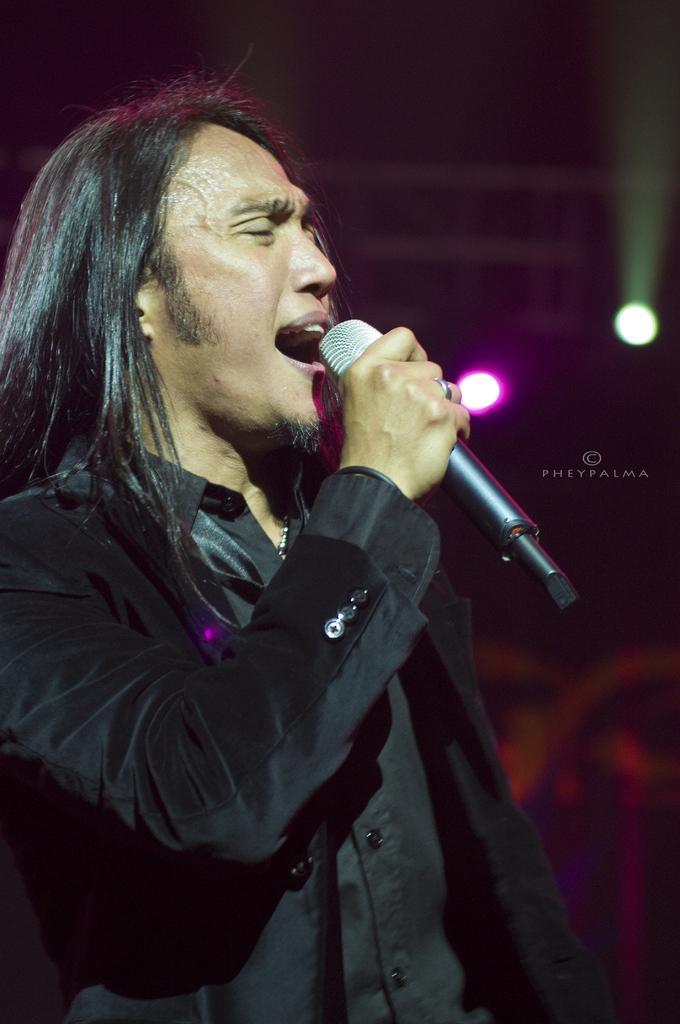How would you summarize this image in a sentence or two? In this picture we can see a man in the black blazer and the man is holding a microphone and singing a song. Behind the man there is the dark background and two lights. On the image there is a watermark. 